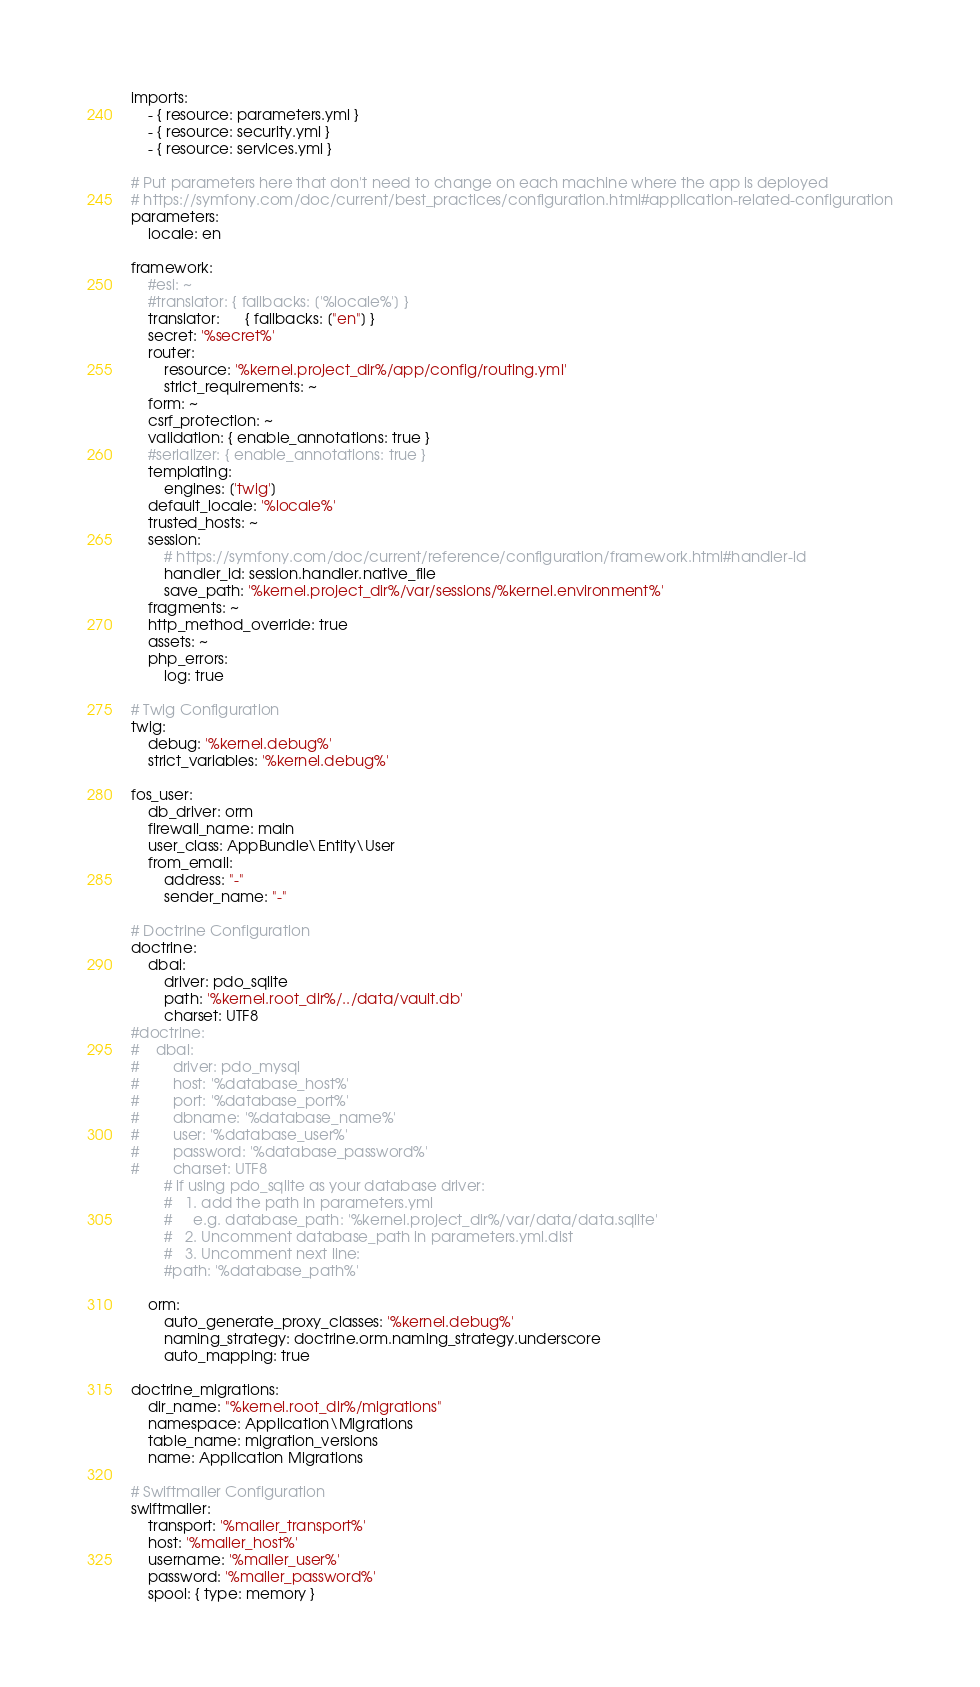<code> <loc_0><loc_0><loc_500><loc_500><_YAML_>imports:
    - { resource: parameters.yml }
    - { resource: security.yml }
    - { resource: services.yml }

# Put parameters here that don't need to change on each machine where the app is deployed
# https://symfony.com/doc/current/best_practices/configuration.html#application-related-configuration
parameters:
    locale: en

framework:
    #esi: ~
    #translator: { fallbacks: ['%locale%'] }
    translator:      { fallbacks: ["en"] }
    secret: '%secret%'
    router:
        resource: '%kernel.project_dir%/app/config/routing.yml'
        strict_requirements: ~
    form: ~
    csrf_protection: ~
    validation: { enable_annotations: true }
    #serializer: { enable_annotations: true }
    templating:
        engines: ['twig']
    default_locale: '%locale%'
    trusted_hosts: ~
    session:
        # https://symfony.com/doc/current/reference/configuration/framework.html#handler-id
        handler_id: session.handler.native_file
        save_path: '%kernel.project_dir%/var/sessions/%kernel.environment%'
    fragments: ~
    http_method_override: true
    assets: ~
    php_errors:
        log: true

# Twig Configuration
twig:
    debug: '%kernel.debug%'
    strict_variables: '%kernel.debug%'
    
fos_user:
    db_driver: orm
    firewall_name: main
    user_class: AppBundle\Entity\User
    from_email:
        address: "-"
        sender_name: "-"

# Doctrine Configuration
doctrine:
    dbal:
        driver: pdo_sqlite
        path: '%kernel.root_dir%/../data/vault.db'
        charset: UTF8
#doctrine:
#    dbal:
#        driver: pdo_mysql
#        host: '%database_host%'
#        port: '%database_port%'
#        dbname: '%database_name%'
#        user: '%database_user%'
#        password: '%database_password%'
#        charset: UTF8
        # if using pdo_sqlite as your database driver:
        #   1. add the path in parameters.yml
        #     e.g. database_path: '%kernel.project_dir%/var/data/data.sqlite'
        #   2. Uncomment database_path in parameters.yml.dist
        #   3. Uncomment next line:
        #path: '%database_path%'

    orm:
        auto_generate_proxy_classes: '%kernel.debug%'
        naming_strategy: doctrine.orm.naming_strategy.underscore
        auto_mapping: true

doctrine_migrations:
    dir_name: "%kernel.root_dir%/migrations"
    namespace: Application\Migrations
    table_name: migration_versions
    name: Application Migrations

# Swiftmailer Configuration
swiftmailer:
    transport: '%mailer_transport%'
    host: '%mailer_host%'
    username: '%mailer_user%'
    password: '%mailer_password%'
    spool: { type: memory }
</code> 